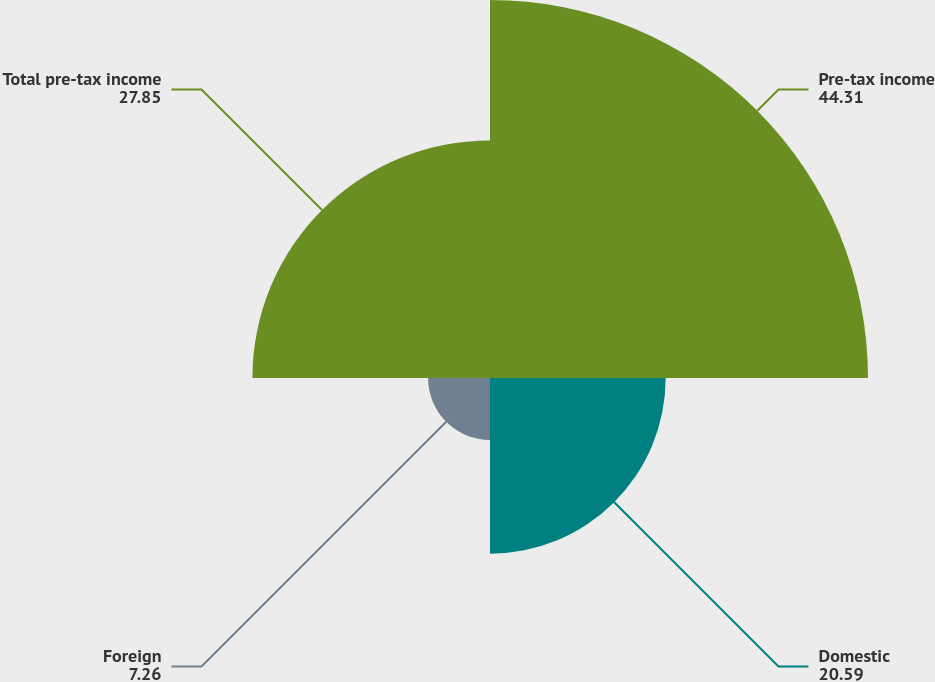Convert chart. <chart><loc_0><loc_0><loc_500><loc_500><pie_chart><fcel>Pre-tax income<fcel>Domestic<fcel>Foreign<fcel>Total pre-tax income<nl><fcel>44.31%<fcel>20.59%<fcel>7.26%<fcel>27.85%<nl></chart> 